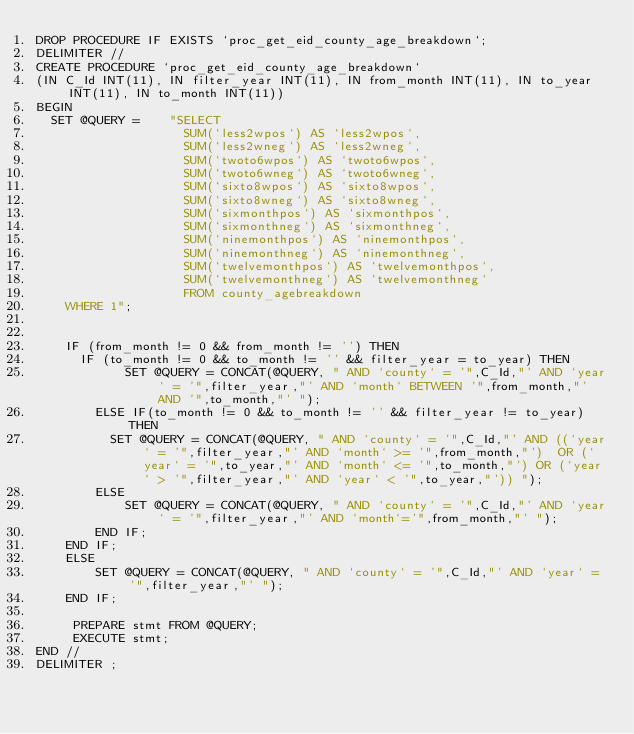<code> <loc_0><loc_0><loc_500><loc_500><_SQL_>DROP PROCEDURE IF EXISTS `proc_get_eid_county_age_breakdown`;
DELIMITER //
CREATE PROCEDURE `proc_get_eid_county_age_breakdown`
(IN C_Id INT(11), IN filter_year INT(11), IN from_month INT(11), IN to_year INT(11), IN to_month INT(11))
BEGIN
  SET @QUERY =    "SELECT 
                    SUM(`less2wpos`) AS `less2wpos`,
                    SUM(`less2wneg`) AS `less2wneg`,
                    SUM(`twoto6wpos`) AS `twoto6wpos`,
                    SUM(`twoto6wneg`) AS `twoto6wneg`,
                    SUM(`sixto8wpos`) AS `sixto8wpos`,
                    SUM(`sixto8wneg`) AS `sixto8wneg`,
                    SUM(`sixmonthpos`) AS `sixmonthpos`,
                    SUM(`sixmonthneg`) AS `sixmonthneg`,
                    SUM(`ninemonthpos`) AS `ninemonthpos`,
                    SUM(`ninemonthneg`) AS `ninemonthneg`,
                    SUM(`twelvemonthpos`) AS `twelvemonthpos`,
                    SUM(`twelvemonthneg`) AS `twelvemonthneg`
                    FROM county_agebreakdown
    WHERE 1";


    IF (from_month != 0 && from_month != '') THEN
      IF (to_month != 0 && to_month != '' && filter_year = to_year) THEN
            SET @QUERY = CONCAT(@QUERY, " AND `county` = '",C_Id,"' AND `year` = '",filter_year,"' AND `month` BETWEEN '",from_month,"' AND '",to_month,"' ");
        ELSE IF(to_month != 0 && to_month != '' && filter_year != to_year) THEN
          SET @QUERY = CONCAT(@QUERY, " AND `county` = '",C_Id,"' AND ((`year` = '",filter_year,"' AND `month` >= '",from_month,"')  OR (`year` = '",to_year,"' AND `month` <= '",to_month,"') OR (`year` > '",filter_year,"' AND `year` < '",to_year,"')) ");
        ELSE
            SET @QUERY = CONCAT(@QUERY, " AND `county` = '",C_Id,"' AND `year` = '",filter_year,"' AND `month`='",from_month,"' ");
        END IF;
    END IF;
    ELSE
        SET @QUERY = CONCAT(@QUERY, " AND `county` = '",C_Id,"' AND `year` = '",filter_year,"' ");
    END IF;

     PREPARE stmt FROM @QUERY;
     EXECUTE stmt;
END //
DELIMITER ;
</code> 